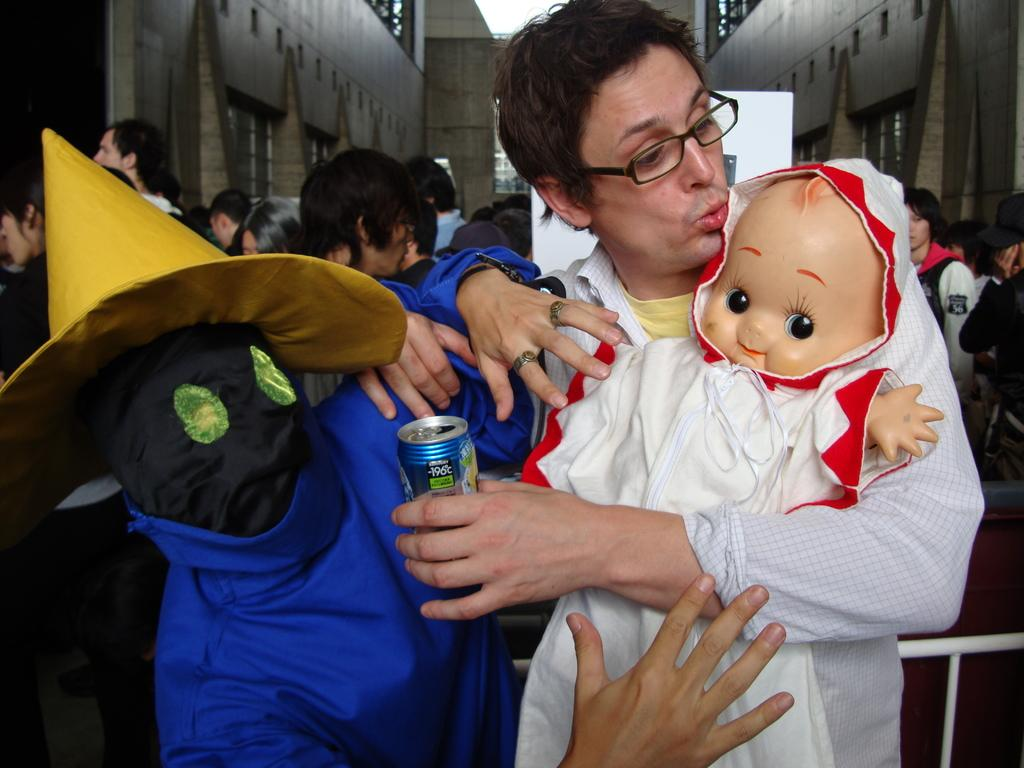How many people are in the image? There are people in the image. What is one person doing with an object in the image? One person is holding a toy and looking at it. Can you describe the appearance of one person in the image? There is a person wearing a mask in the image. What type of reaction can be seen on the person's teeth in the image? There is no reference to teeth or a reaction in the image, as it features people holding a toy and wearing a mask. 